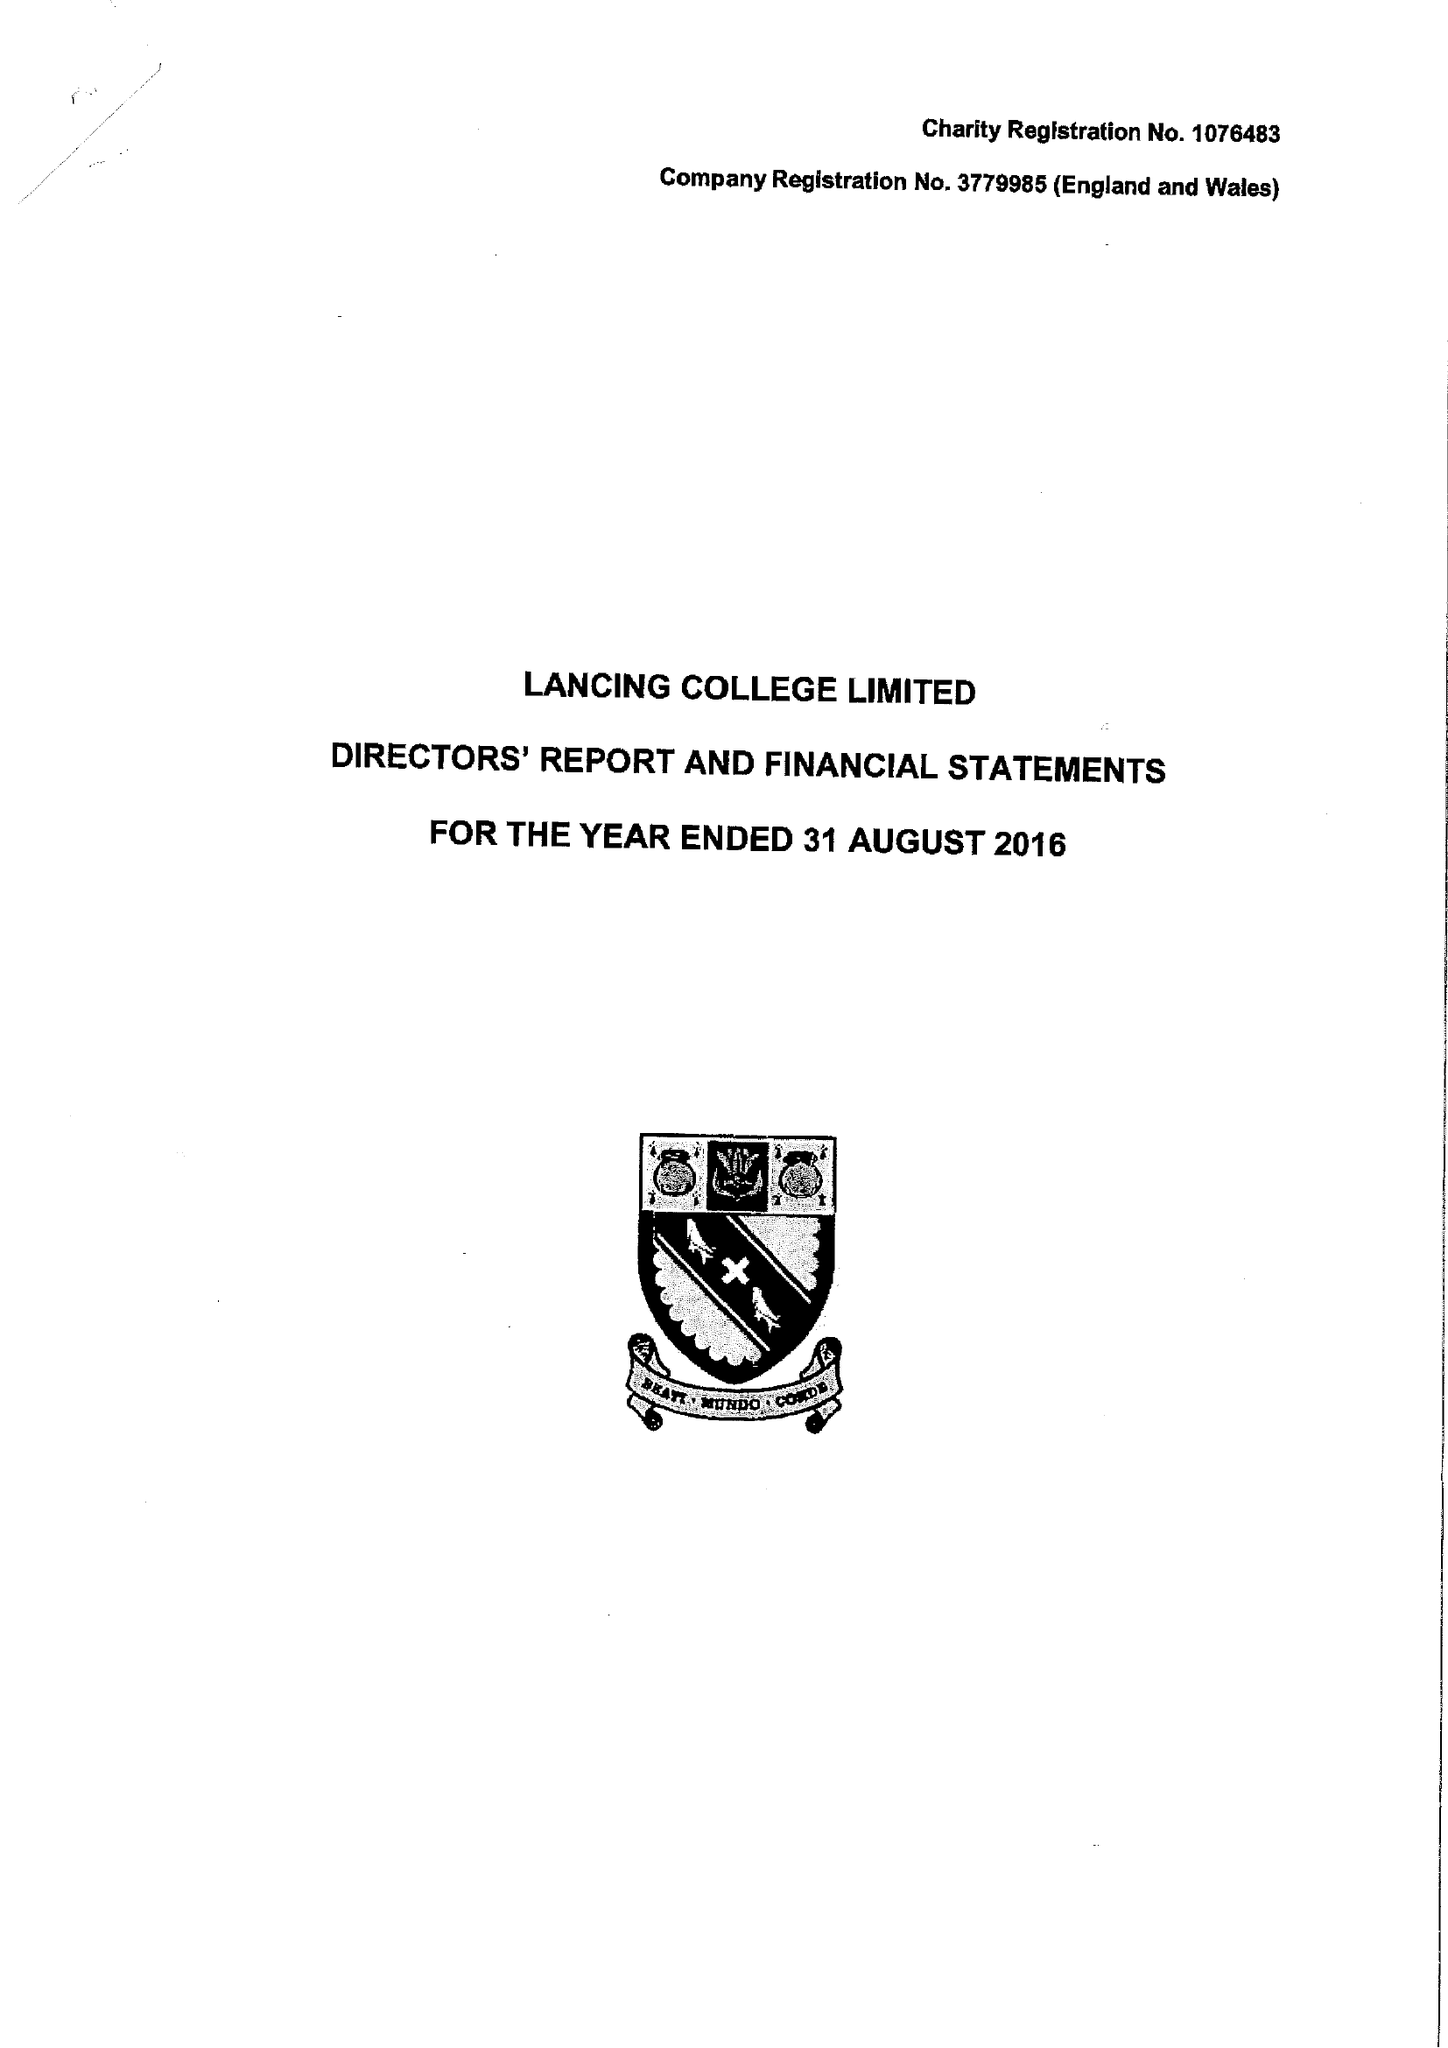What is the value for the report_date?
Answer the question using a single word or phrase. 2016-08-31 